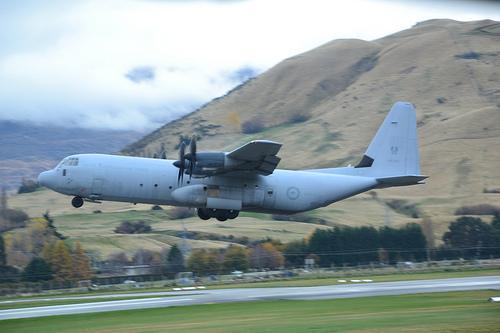How many airplanes are in picture?
Give a very brief answer. 1. 